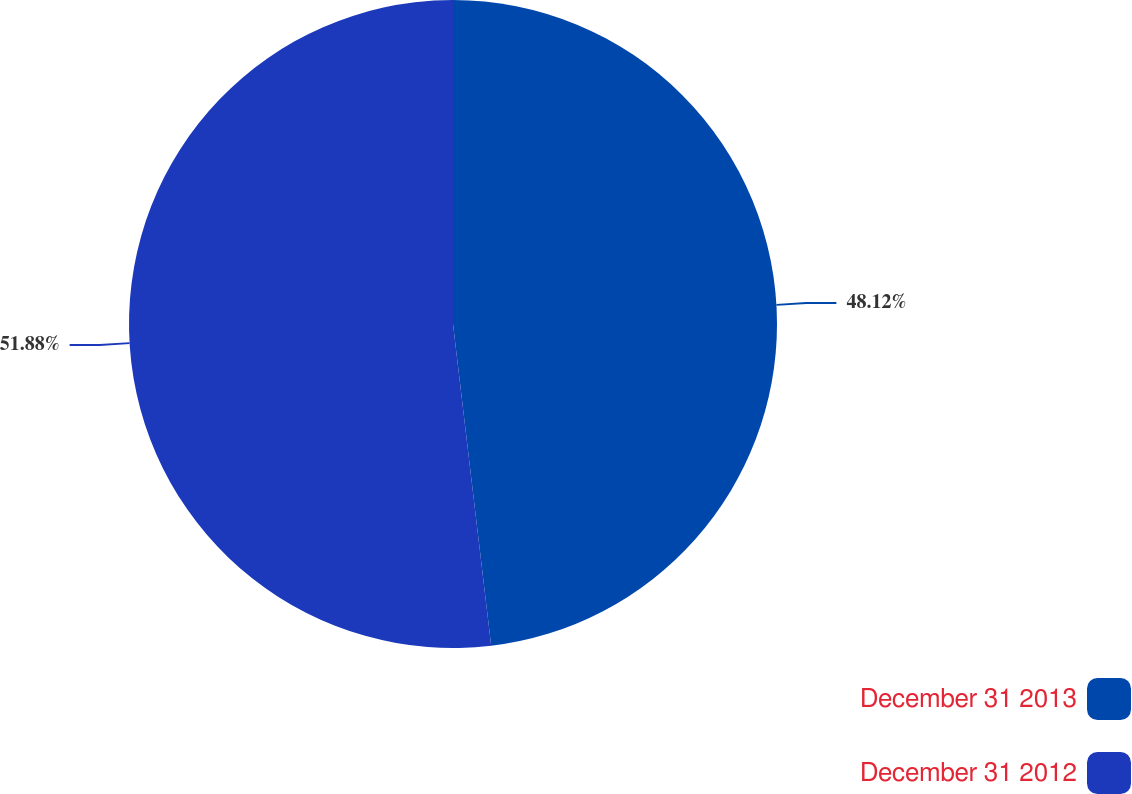Convert chart. <chart><loc_0><loc_0><loc_500><loc_500><pie_chart><fcel>December 31 2013<fcel>December 31 2012<nl><fcel>48.12%<fcel>51.88%<nl></chart> 